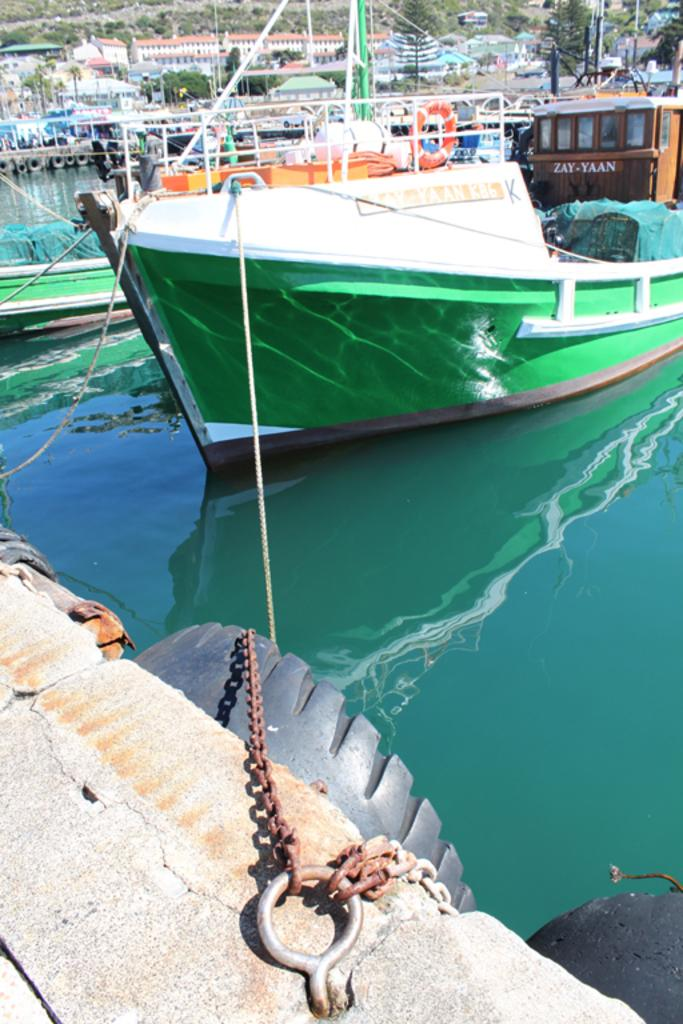What is the main subject of the image? The main subject of the image is a ship. How is the ship secured in the image? The ship is tied to a hook in the image. What can be seen in the background of the image? There are buildings, other ships, water, and trees visible in the background of the image. What type of plastic material is used to build the army barracks in the image? There is no plastic material or army barracks present in the image. 